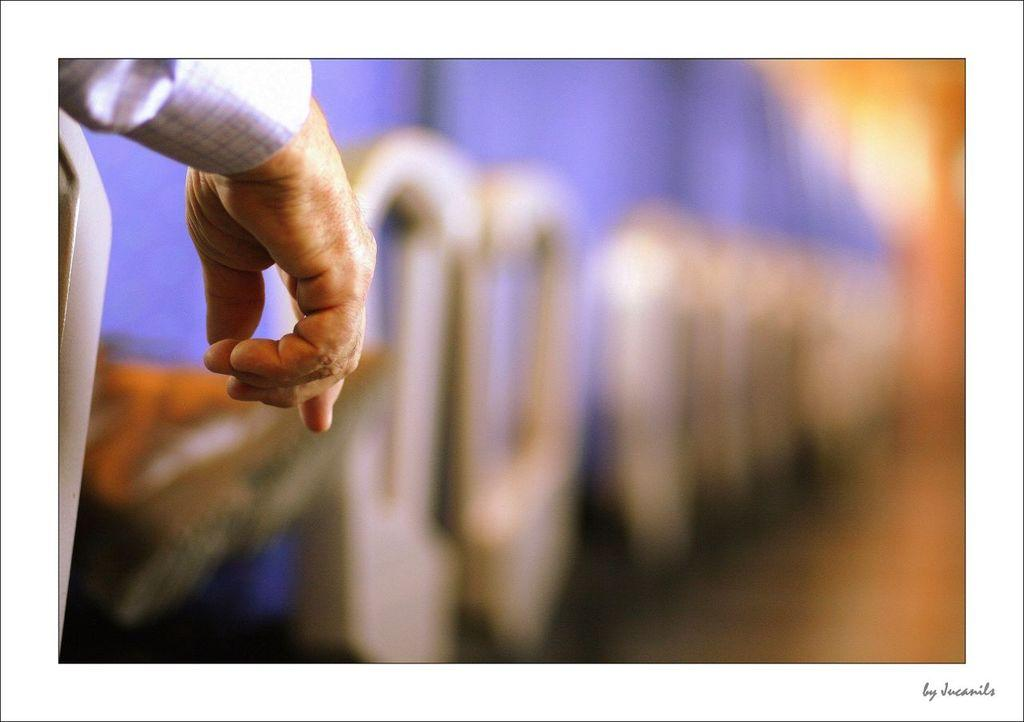What can be seen on the left side of the image? There is a person's hand on the left side of the image. How would you describe the background of the image? The background of the image is blurred. Can you identify any objects in the background? Yes, there are visible objects in the background. Where is the text located in the image? The text is in the bottom right corner of the image. What type of trail does the person's hand follow in the image? There is no trail visible in the image, as it only shows a person's hand and a blurred background. 